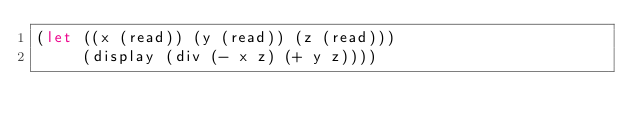<code> <loc_0><loc_0><loc_500><loc_500><_Scheme_>(let ((x (read)) (y (read)) (z (read)))
     (display (div (- x z) (+ y z))))</code> 